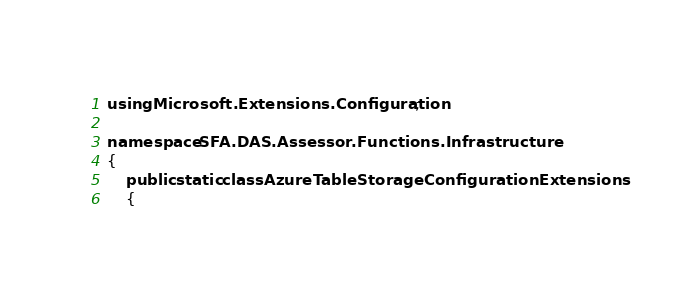Convert code to text. <code><loc_0><loc_0><loc_500><loc_500><_C#_>using Microsoft.Extensions.Configuration;

namespace SFA.DAS.Assessor.Functions.Infrastructure
{
    public static class AzureTableStorageConfigurationExtensions
    {</code> 